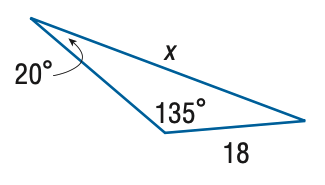Answer the mathemtical geometry problem and directly provide the correct option letter.
Question: Find x. Round the side measure to the nearest tenth.
Choices: A: 8.7 B: 14.6 C: 22.2 D: 37.2 D 